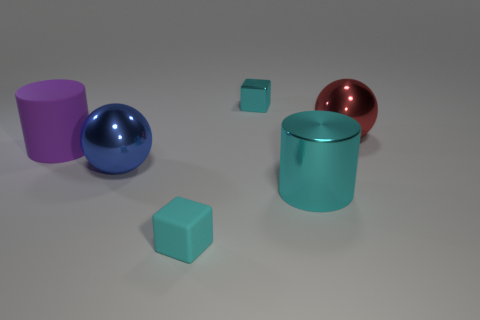Can you tell me the colors of the objects in the image? Certainly! In the image, there is a purple cylinder, a blue sphere, a turquoise cylinder, a small turquoise cube, and a red sphere. 